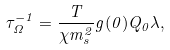<formula> <loc_0><loc_0><loc_500><loc_500>\tau ^ { - 1 } _ { \Omega } = \frac { T } { \chi m _ { s } ^ { 2 } } g ( 0 ) Q _ { 0 } \lambda ,</formula> 